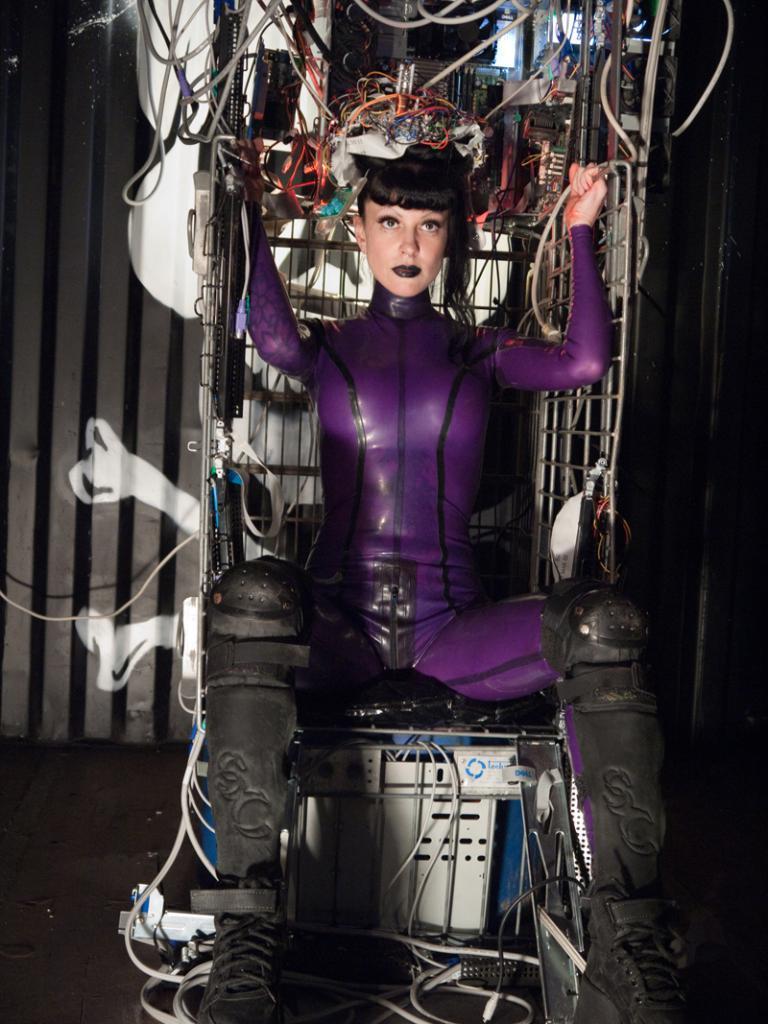Could you give a brief overview of what you see in this image? In the image there is a woman sitting on some electronic gadget and she is holding something with her hands and on her head there are some electronic objects. 